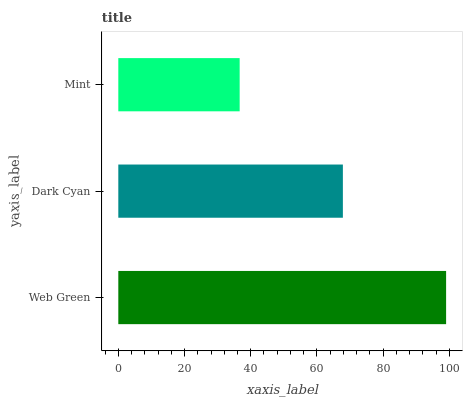Is Mint the minimum?
Answer yes or no. Yes. Is Web Green the maximum?
Answer yes or no. Yes. Is Dark Cyan the minimum?
Answer yes or no. No. Is Dark Cyan the maximum?
Answer yes or no. No. Is Web Green greater than Dark Cyan?
Answer yes or no. Yes. Is Dark Cyan less than Web Green?
Answer yes or no. Yes. Is Dark Cyan greater than Web Green?
Answer yes or no. No. Is Web Green less than Dark Cyan?
Answer yes or no. No. Is Dark Cyan the high median?
Answer yes or no. Yes. Is Dark Cyan the low median?
Answer yes or no. Yes. Is Web Green the high median?
Answer yes or no. No. Is Mint the low median?
Answer yes or no. No. 